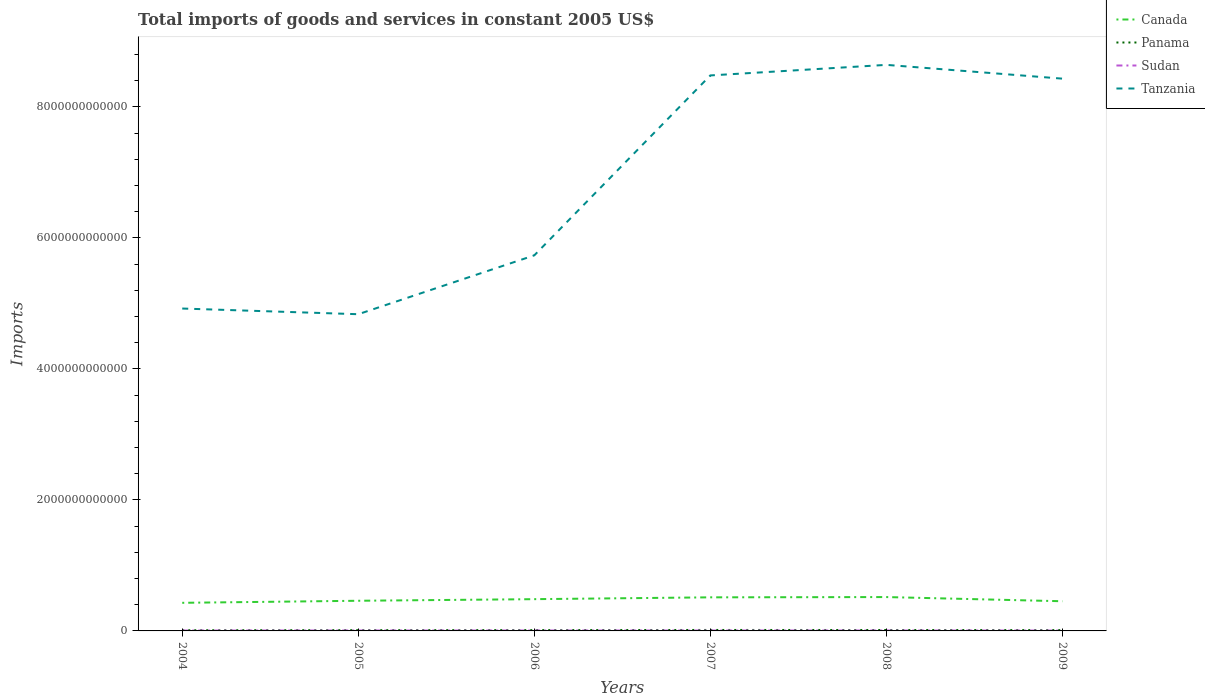Does the line corresponding to Sudan intersect with the line corresponding to Panama?
Your response must be concise. No. Is the number of lines equal to the number of legend labels?
Your answer should be very brief. Yes. Across all years, what is the maximum total imports of goods and services in Canada?
Ensure brevity in your answer.  4.29e+11. In which year was the total imports of goods and services in Tanzania maximum?
Provide a succinct answer. 2005. What is the total total imports of goods and services in Sudan in the graph?
Provide a short and direct response. 2.44e+08. What is the difference between the highest and the second highest total imports of goods and services in Canada?
Provide a succinct answer. 8.79e+1. What is the difference between the highest and the lowest total imports of goods and services in Canada?
Your response must be concise. 3. Is the total imports of goods and services in Tanzania strictly greater than the total imports of goods and services in Panama over the years?
Give a very brief answer. No. What is the difference between two consecutive major ticks on the Y-axis?
Keep it short and to the point. 2.00e+12. What is the title of the graph?
Your response must be concise. Total imports of goods and services in constant 2005 US$. What is the label or title of the Y-axis?
Provide a short and direct response. Imports. What is the Imports in Canada in 2004?
Keep it short and to the point. 4.29e+11. What is the Imports of Panama in 2004?
Offer a terse response. 1.04e+1. What is the Imports of Sudan in 2004?
Offer a terse response. 5.89e+09. What is the Imports of Tanzania in 2004?
Provide a succinct answer. 4.92e+12. What is the Imports of Canada in 2005?
Provide a succinct answer. 4.61e+11. What is the Imports of Panama in 2005?
Keep it short and to the point. 1.15e+1. What is the Imports of Sudan in 2005?
Offer a terse response. 6.37e+09. What is the Imports of Tanzania in 2005?
Your response must be concise. 4.84e+12. What is the Imports in Canada in 2006?
Provide a succinct answer. 4.85e+11. What is the Imports in Panama in 2006?
Your response must be concise. 1.24e+1. What is the Imports in Sudan in 2006?
Your answer should be compact. 6.09e+09. What is the Imports of Tanzania in 2006?
Make the answer very short. 5.73e+12. What is the Imports of Canada in 2007?
Provide a short and direct response. 5.13e+11. What is the Imports in Panama in 2007?
Ensure brevity in your answer.  1.46e+1. What is the Imports of Sudan in 2007?
Your response must be concise. 6.11e+09. What is the Imports of Tanzania in 2007?
Your response must be concise. 8.48e+12. What is the Imports of Canada in 2008?
Ensure brevity in your answer.  5.17e+11. What is the Imports of Panama in 2008?
Ensure brevity in your answer.  1.40e+1. What is the Imports of Sudan in 2008?
Ensure brevity in your answer.  6.12e+09. What is the Imports in Tanzania in 2008?
Your answer should be very brief. 8.64e+12. What is the Imports of Canada in 2009?
Offer a terse response. 4.53e+11. What is the Imports of Panama in 2009?
Offer a terse response. 1.23e+1. What is the Imports in Sudan in 2009?
Your answer should be compact. 5.68e+09. What is the Imports in Tanzania in 2009?
Offer a terse response. 8.43e+12. Across all years, what is the maximum Imports of Canada?
Keep it short and to the point. 5.17e+11. Across all years, what is the maximum Imports of Panama?
Offer a terse response. 1.46e+1. Across all years, what is the maximum Imports of Sudan?
Offer a very short reply. 6.37e+09. Across all years, what is the maximum Imports of Tanzania?
Make the answer very short. 8.64e+12. Across all years, what is the minimum Imports in Canada?
Provide a short and direct response. 4.29e+11. Across all years, what is the minimum Imports in Panama?
Keep it short and to the point. 1.04e+1. Across all years, what is the minimum Imports of Sudan?
Ensure brevity in your answer.  5.68e+09. Across all years, what is the minimum Imports of Tanzania?
Make the answer very short. 4.84e+12. What is the total Imports in Canada in the graph?
Provide a succinct answer. 2.86e+12. What is the total Imports of Panama in the graph?
Provide a short and direct response. 7.52e+1. What is the total Imports in Sudan in the graph?
Offer a very short reply. 3.62e+1. What is the total Imports of Tanzania in the graph?
Give a very brief answer. 4.11e+13. What is the difference between the Imports of Canada in 2004 and that in 2005?
Keep it short and to the point. -3.14e+1. What is the difference between the Imports of Panama in 2004 and that in 2005?
Your answer should be compact. -1.16e+09. What is the difference between the Imports in Sudan in 2004 and that in 2005?
Your answer should be very brief. -4.80e+08. What is the difference between the Imports of Tanzania in 2004 and that in 2005?
Offer a terse response. 8.68e+1. What is the difference between the Imports in Canada in 2004 and that in 2006?
Keep it short and to the point. -5.58e+1. What is the difference between the Imports of Panama in 2004 and that in 2006?
Offer a very short reply. -2.02e+09. What is the difference between the Imports in Sudan in 2004 and that in 2006?
Your answer should be very brief. -2.00e+08. What is the difference between the Imports of Tanzania in 2004 and that in 2006?
Give a very brief answer. -8.12e+11. What is the difference between the Imports of Canada in 2004 and that in 2007?
Provide a short and direct response. -8.37e+1. What is the difference between the Imports in Panama in 2004 and that in 2007?
Make the answer very short. -4.25e+09. What is the difference between the Imports in Sudan in 2004 and that in 2007?
Provide a succinct answer. -2.18e+08. What is the difference between the Imports of Tanzania in 2004 and that in 2007?
Offer a terse response. -3.56e+12. What is the difference between the Imports in Canada in 2004 and that in 2008?
Your response must be concise. -8.79e+1. What is the difference between the Imports in Panama in 2004 and that in 2008?
Offer a very short reply. -3.59e+09. What is the difference between the Imports in Sudan in 2004 and that in 2008?
Provide a succinct answer. -2.36e+08. What is the difference between the Imports in Tanzania in 2004 and that in 2008?
Provide a succinct answer. -3.72e+12. What is the difference between the Imports in Canada in 2004 and that in 2009?
Ensure brevity in your answer.  -2.40e+1. What is the difference between the Imports of Panama in 2004 and that in 2009?
Offer a very short reply. -1.88e+09. What is the difference between the Imports in Sudan in 2004 and that in 2009?
Offer a terse response. 2.12e+08. What is the difference between the Imports of Tanzania in 2004 and that in 2009?
Provide a succinct answer. -3.51e+12. What is the difference between the Imports of Canada in 2005 and that in 2006?
Offer a very short reply. -2.44e+1. What is the difference between the Imports in Panama in 2005 and that in 2006?
Offer a very short reply. -8.57e+08. What is the difference between the Imports of Sudan in 2005 and that in 2006?
Ensure brevity in your answer.  2.80e+08. What is the difference between the Imports of Tanzania in 2005 and that in 2006?
Offer a very short reply. -8.99e+11. What is the difference between the Imports in Canada in 2005 and that in 2007?
Offer a very short reply. -5.23e+1. What is the difference between the Imports of Panama in 2005 and that in 2007?
Offer a terse response. -3.09e+09. What is the difference between the Imports in Sudan in 2005 and that in 2007?
Offer a very short reply. 2.62e+08. What is the difference between the Imports in Tanzania in 2005 and that in 2007?
Your answer should be compact. -3.65e+12. What is the difference between the Imports of Canada in 2005 and that in 2008?
Make the answer very short. -5.65e+1. What is the difference between the Imports of Panama in 2005 and that in 2008?
Your response must be concise. -2.43e+09. What is the difference between the Imports in Sudan in 2005 and that in 2008?
Offer a very short reply. 2.44e+08. What is the difference between the Imports in Tanzania in 2005 and that in 2008?
Offer a very short reply. -3.81e+12. What is the difference between the Imports of Canada in 2005 and that in 2009?
Give a very brief answer. 7.42e+09. What is the difference between the Imports in Panama in 2005 and that in 2009?
Give a very brief answer. -7.20e+08. What is the difference between the Imports in Sudan in 2005 and that in 2009?
Provide a short and direct response. 6.92e+08. What is the difference between the Imports of Tanzania in 2005 and that in 2009?
Keep it short and to the point. -3.60e+12. What is the difference between the Imports in Canada in 2006 and that in 2007?
Your answer should be compact. -2.79e+1. What is the difference between the Imports of Panama in 2006 and that in 2007?
Provide a short and direct response. -2.24e+09. What is the difference between the Imports in Sudan in 2006 and that in 2007?
Your response must be concise. -1.80e+07. What is the difference between the Imports of Tanzania in 2006 and that in 2007?
Make the answer very short. -2.75e+12. What is the difference between the Imports in Canada in 2006 and that in 2008?
Offer a terse response. -3.21e+1. What is the difference between the Imports in Panama in 2006 and that in 2008?
Provide a short and direct response. -1.57e+09. What is the difference between the Imports of Sudan in 2006 and that in 2008?
Provide a short and direct response. -3.60e+07. What is the difference between the Imports in Tanzania in 2006 and that in 2008?
Ensure brevity in your answer.  -2.91e+12. What is the difference between the Imports in Canada in 2006 and that in 2009?
Give a very brief answer. 3.19e+1. What is the difference between the Imports in Panama in 2006 and that in 2009?
Offer a terse response. 1.37e+08. What is the difference between the Imports in Sudan in 2006 and that in 2009?
Give a very brief answer. 4.12e+08. What is the difference between the Imports of Tanzania in 2006 and that in 2009?
Your answer should be very brief. -2.70e+12. What is the difference between the Imports in Canada in 2007 and that in 2008?
Offer a very short reply. -4.19e+09. What is the difference between the Imports of Panama in 2007 and that in 2008?
Offer a very short reply. 6.65e+08. What is the difference between the Imports in Sudan in 2007 and that in 2008?
Your response must be concise. -1.79e+07. What is the difference between the Imports of Tanzania in 2007 and that in 2008?
Your response must be concise. -1.61e+11. What is the difference between the Imports of Canada in 2007 and that in 2009?
Offer a very short reply. 5.97e+1. What is the difference between the Imports in Panama in 2007 and that in 2009?
Offer a terse response. 2.37e+09. What is the difference between the Imports of Sudan in 2007 and that in 2009?
Offer a terse response. 4.30e+08. What is the difference between the Imports of Tanzania in 2007 and that in 2009?
Ensure brevity in your answer.  4.91e+1. What is the difference between the Imports of Canada in 2008 and that in 2009?
Your answer should be very brief. 6.39e+1. What is the difference between the Imports of Panama in 2008 and that in 2009?
Keep it short and to the point. 1.71e+09. What is the difference between the Imports in Sudan in 2008 and that in 2009?
Offer a terse response. 4.48e+08. What is the difference between the Imports in Tanzania in 2008 and that in 2009?
Give a very brief answer. 2.11e+11. What is the difference between the Imports of Canada in 2004 and the Imports of Panama in 2005?
Ensure brevity in your answer.  4.18e+11. What is the difference between the Imports of Canada in 2004 and the Imports of Sudan in 2005?
Ensure brevity in your answer.  4.23e+11. What is the difference between the Imports in Canada in 2004 and the Imports in Tanzania in 2005?
Make the answer very short. -4.41e+12. What is the difference between the Imports in Panama in 2004 and the Imports in Sudan in 2005?
Provide a succinct answer. 4.01e+09. What is the difference between the Imports in Panama in 2004 and the Imports in Tanzania in 2005?
Keep it short and to the point. -4.83e+12. What is the difference between the Imports of Sudan in 2004 and the Imports of Tanzania in 2005?
Keep it short and to the point. -4.83e+12. What is the difference between the Imports of Canada in 2004 and the Imports of Panama in 2006?
Offer a very short reply. 4.17e+11. What is the difference between the Imports of Canada in 2004 and the Imports of Sudan in 2006?
Provide a short and direct response. 4.23e+11. What is the difference between the Imports of Canada in 2004 and the Imports of Tanzania in 2006?
Provide a short and direct response. -5.31e+12. What is the difference between the Imports of Panama in 2004 and the Imports of Sudan in 2006?
Offer a terse response. 4.29e+09. What is the difference between the Imports in Panama in 2004 and the Imports in Tanzania in 2006?
Ensure brevity in your answer.  -5.72e+12. What is the difference between the Imports of Sudan in 2004 and the Imports of Tanzania in 2006?
Give a very brief answer. -5.73e+12. What is the difference between the Imports of Canada in 2004 and the Imports of Panama in 2007?
Ensure brevity in your answer.  4.15e+11. What is the difference between the Imports in Canada in 2004 and the Imports in Sudan in 2007?
Your answer should be very brief. 4.23e+11. What is the difference between the Imports of Canada in 2004 and the Imports of Tanzania in 2007?
Your answer should be compact. -8.05e+12. What is the difference between the Imports in Panama in 2004 and the Imports in Sudan in 2007?
Keep it short and to the point. 4.28e+09. What is the difference between the Imports in Panama in 2004 and the Imports in Tanzania in 2007?
Provide a short and direct response. -8.47e+12. What is the difference between the Imports in Sudan in 2004 and the Imports in Tanzania in 2007?
Ensure brevity in your answer.  -8.48e+12. What is the difference between the Imports in Canada in 2004 and the Imports in Panama in 2008?
Ensure brevity in your answer.  4.15e+11. What is the difference between the Imports in Canada in 2004 and the Imports in Sudan in 2008?
Your answer should be very brief. 4.23e+11. What is the difference between the Imports of Canada in 2004 and the Imports of Tanzania in 2008?
Offer a terse response. -8.21e+12. What is the difference between the Imports in Panama in 2004 and the Imports in Sudan in 2008?
Your response must be concise. 4.26e+09. What is the difference between the Imports of Panama in 2004 and the Imports of Tanzania in 2008?
Your answer should be very brief. -8.63e+12. What is the difference between the Imports in Sudan in 2004 and the Imports in Tanzania in 2008?
Give a very brief answer. -8.64e+12. What is the difference between the Imports of Canada in 2004 and the Imports of Panama in 2009?
Your response must be concise. 4.17e+11. What is the difference between the Imports of Canada in 2004 and the Imports of Sudan in 2009?
Your response must be concise. 4.23e+11. What is the difference between the Imports in Canada in 2004 and the Imports in Tanzania in 2009?
Provide a short and direct response. -8.00e+12. What is the difference between the Imports of Panama in 2004 and the Imports of Sudan in 2009?
Your answer should be very brief. 4.71e+09. What is the difference between the Imports of Panama in 2004 and the Imports of Tanzania in 2009?
Ensure brevity in your answer.  -8.42e+12. What is the difference between the Imports in Sudan in 2004 and the Imports in Tanzania in 2009?
Offer a terse response. -8.43e+12. What is the difference between the Imports of Canada in 2005 and the Imports of Panama in 2006?
Offer a very short reply. 4.48e+11. What is the difference between the Imports in Canada in 2005 and the Imports in Sudan in 2006?
Provide a succinct answer. 4.54e+11. What is the difference between the Imports of Canada in 2005 and the Imports of Tanzania in 2006?
Provide a succinct answer. -5.27e+12. What is the difference between the Imports of Panama in 2005 and the Imports of Sudan in 2006?
Offer a terse response. 5.45e+09. What is the difference between the Imports of Panama in 2005 and the Imports of Tanzania in 2006?
Ensure brevity in your answer.  -5.72e+12. What is the difference between the Imports of Sudan in 2005 and the Imports of Tanzania in 2006?
Provide a succinct answer. -5.73e+12. What is the difference between the Imports of Canada in 2005 and the Imports of Panama in 2007?
Give a very brief answer. 4.46e+11. What is the difference between the Imports in Canada in 2005 and the Imports in Sudan in 2007?
Your answer should be compact. 4.54e+11. What is the difference between the Imports of Canada in 2005 and the Imports of Tanzania in 2007?
Keep it short and to the point. -8.02e+12. What is the difference between the Imports of Panama in 2005 and the Imports of Sudan in 2007?
Provide a short and direct response. 5.44e+09. What is the difference between the Imports in Panama in 2005 and the Imports in Tanzania in 2007?
Provide a succinct answer. -8.47e+12. What is the difference between the Imports in Sudan in 2005 and the Imports in Tanzania in 2007?
Offer a very short reply. -8.48e+12. What is the difference between the Imports of Canada in 2005 and the Imports of Panama in 2008?
Your answer should be very brief. 4.47e+11. What is the difference between the Imports in Canada in 2005 and the Imports in Sudan in 2008?
Keep it short and to the point. 4.54e+11. What is the difference between the Imports in Canada in 2005 and the Imports in Tanzania in 2008?
Offer a terse response. -8.18e+12. What is the difference between the Imports in Panama in 2005 and the Imports in Sudan in 2008?
Your response must be concise. 5.42e+09. What is the difference between the Imports in Panama in 2005 and the Imports in Tanzania in 2008?
Give a very brief answer. -8.63e+12. What is the difference between the Imports in Sudan in 2005 and the Imports in Tanzania in 2008?
Offer a very short reply. -8.64e+12. What is the difference between the Imports in Canada in 2005 and the Imports in Panama in 2009?
Your answer should be very brief. 4.48e+11. What is the difference between the Imports of Canada in 2005 and the Imports of Sudan in 2009?
Make the answer very short. 4.55e+11. What is the difference between the Imports in Canada in 2005 and the Imports in Tanzania in 2009?
Your response must be concise. -7.97e+12. What is the difference between the Imports in Panama in 2005 and the Imports in Sudan in 2009?
Keep it short and to the point. 5.87e+09. What is the difference between the Imports in Panama in 2005 and the Imports in Tanzania in 2009?
Your response must be concise. -8.42e+12. What is the difference between the Imports of Sudan in 2005 and the Imports of Tanzania in 2009?
Your answer should be very brief. -8.43e+12. What is the difference between the Imports in Canada in 2006 and the Imports in Panama in 2007?
Your answer should be very brief. 4.70e+11. What is the difference between the Imports in Canada in 2006 and the Imports in Sudan in 2007?
Offer a very short reply. 4.79e+11. What is the difference between the Imports of Canada in 2006 and the Imports of Tanzania in 2007?
Offer a terse response. -8.00e+12. What is the difference between the Imports in Panama in 2006 and the Imports in Sudan in 2007?
Ensure brevity in your answer.  6.29e+09. What is the difference between the Imports of Panama in 2006 and the Imports of Tanzania in 2007?
Ensure brevity in your answer.  -8.47e+12. What is the difference between the Imports of Sudan in 2006 and the Imports of Tanzania in 2007?
Keep it short and to the point. -8.48e+12. What is the difference between the Imports in Canada in 2006 and the Imports in Panama in 2008?
Your answer should be very brief. 4.71e+11. What is the difference between the Imports in Canada in 2006 and the Imports in Sudan in 2008?
Keep it short and to the point. 4.79e+11. What is the difference between the Imports in Canada in 2006 and the Imports in Tanzania in 2008?
Provide a short and direct response. -8.16e+12. What is the difference between the Imports of Panama in 2006 and the Imports of Sudan in 2008?
Your answer should be compact. 6.27e+09. What is the difference between the Imports in Panama in 2006 and the Imports in Tanzania in 2008?
Your answer should be very brief. -8.63e+12. What is the difference between the Imports in Sudan in 2006 and the Imports in Tanzania in 2008?
Your answer should be compact. -8.64e+12. What is the difference between the Imports in Canada in 2006 and the Imports in Panama in 2009?
Ensure brevity in your answer.  4.73e+11. What is the difference between the Imports in Canada in 2006 and the Imports in Sudan in 2009?
Your answer should be very brief. 4.79e+11. What is the difference between the Imports in Canada in 2006 and the Imports in Tanzania in 2009?
Keep it short and to the point. -7.95e+12. What is the difference between the Imports in Panama in 2006 and the Imports in Sudan in 2009?
Provide a succinct answer. 6.72e+09. What is the difference between the Imports of Panama in 2006 and the Imports of Tanzania in 2009?
Give a very brief answer. -8.42e+12. What is the difference between the Imports of Sudan in 2006 and the Imports of Tanzania in 2009?
Keep it short and to the point. -8.43e+12. What is the difference between the Imports in Canada in 2007 and the Imports in Panama in 2008?
Keep it short and to the point. 4.99e+11. What is the difference between the Imports of Canada in 2007 and the Imports of Sudan in 2008?
Offer a terse response. 5.07e+11. What is the difference between the Imports of Canada in 2007 and the Imports of Tanzania in 2008?
Keep it short and to the point. -8.13e+12. What is the difference between the Imports of Panama in 2007 and the Imports of Sudan in 2008?
Give a very brief answer. 8.51e+09. What is the difference between the Imports in Panama in 2007 and the Imports in Tanzania in 2008?
Give a very brief answer. -8.63e+12. What is the difference between the Imports of Sudan in 2007 and the Imports of Tanzania in 2008?
Keep it short and to the point. -8.64e+12. What is the difference between the Imports in Canada in 2007 and the Imports in Panama in 2009?
Make the answer very short. 5.01e+11. What is the difference between the Imports in Canada in 2007 and the Imports in Sudan in 2009?
Provide a succinct answer. 5.07e+11. What is the difference between the Imports in Canada in 2007 and the Imports in Tanzania in 2009?
Your answer should be compact. -7.92e+12. What is the difference between the Imports of Panama in 2007 and the Imports of Sudan in 2009?
Your answer should be very brief. 8.96e+09. What is the difference between the Imports of Panama in 2007 and the Imports of Tanzania in 2009?
Offer a terse response. -8.42e+12. What is the difference between the Imports of Sudan in 2007 and the Imports of Tanzania in 2009?
Your response must be concise. -8.43e+12. What is the difference between the Imports in Canada in 2008 and the Imports in Panama in 2009?
Your answer should be compact. 5.05e+11. What is the difference between the Imports in Canada in 2008 and the Imports in Sudan in 2009?
Provide a succinct answer. 5.11e+11. What is the difference between the Imports in Canada in 2008 and the Imports in Tanzania in 2009?
Offer a very short reply. -7.92e+12. What is the difference between the Imports of Panama in 2008 and the Imports of Sudan in 2009?
Your answer should be very brief. 8.30e+09. What is the difference between the Imports of Panama in 2008 and the Imports of Tanzania in 2009?
Offer a terse response. -8.42e+12. What is the difference between the Imports in Sudan in 2008 and the Imports in Tanzania in 2009?
Provide a short and direct response. -8.43e+12. What is the average Imports in Canada per year?
Give a very brief answer. 4.76e+11. What is the average Imports in Panama per year?
Your answer should be very brief. 1.25e+1. What is the average Imports in Sudan per year?
Offer a very short reply. 6.04e+09. What is the average Imports in Tanzania per year?
Make the answer very short. 6.84e+12. In the year 2004, what is the difference between the Imports of Canada and Imports of Panama?
Provide a short and direct response. 4.19e+11. In the year 2004, what is the difference between the Imports in Canada and Imports in Sudan?
Keep it short and to the point. 4.23e+11. In the year 2004, what is the difference between the Imports of Canada and Imports of Tanzania?
Offer a terse response. -4.49e+12. In the year 2004, what is the difference between the Imports in Panama and Imports in Sudan?
Ensure brevity in your answer.  4.49e+09. In the year 2004, what is the difference between the Imports of Panama and Imports of Tanzania?
Keep it short and to the point. -4.91e+12. In the year 2004, what is the difference between the Imports of Sudan and Imports of Tanzania?
Provide a succinct answer. -4.92e+12. In the year 2005, what is the difference between the Imports in Canada and Imports in Panama?
Keep it short and to the point. 4.49e+11. In the year 2005, what is the difference between the Imports in Canada and Imports in Sudan?
Your answer should be compact. 4.54e+11. In the year 2005, what is the difference between the Imports in Canada and Imports in Tanzania?
Your answer should be compact. -4.38e+12. In the year 2005, what is the difference between the Imports of Panama and Imports of Sudan?
Offer a terse response. 5.17e+09. In the year 2005, what is the difference between the Imports in Panama and Imports in Tanzania?
Make the answer very short. -4.82e+12. In the year 2005, what is the difference between the Imports in Sudan and Imports in Tanzania?
Provide a short and direct response. -4.83e+12. In the year 2006, what is the difference between the Imports of Canada and Imports of Panama?
Your answer should be very brief. 4.73e+11. In the year 2006, what is the difference between the Imports of Canada and Imports of Sudan?
Your answer should be compact. 4.79e+11. In the year 2006, what is the difference between the Imports in Canada and Imports in Tanzania?
Offer a very short reply. -5.25e+12. In the year 2006, what is the difference between the Imports of Panama and Imports of Sudan?
Your response must be concise. 6.31e+09. In the year 2006, what is the difference between the Imports of Panama and Imports of Tanzania?
Offer a very short reply. -5.72e+12. In the year 2006, what is the difference between the Imports of Sudan and Imports of Tanzania?
Your response must be concise. -5.73e+12. In the year 2007, what is the difference between the Imports of Canada and Imports of Panama?
Keep it short and to the point. 4.98e+11. In the year 2007, what is the difference between the Imports of Canada and Imports of Sudan?
Offer a very short reply. 5.07e+11. In the year 2007, what is the difference between the Imports in Canada and Imports in Tanzania?
Give a very brief answer. -7.97e+12. In the year 2007, what is the difference between the Imports of Panama and Imports of Sudan?
Your answer should be compact. 8.53e+09. In the year 2007, what is the difference between the Imports in Panama and Imports in Tanzania?
Keep it short and to the point. -8.47e+12. In the year 2007, what is the difference between the Imports in Sudan and Imports in Tanzania?
Your response must be concise. -8.48e+12. In the year 2008, what is the difference between the Imports in Canada and Imports in Panama?
Provide a short and direct response. 5.03e+11. In the year 2008, what is the difference between the Imports in Canada and Imports in Sudan?
Your answer should be very brief. 5.11e+11. In the year 2008, what is the difference between the Imports in Canada and Imports in Tanzania?
Give a very brief answer. -8.13e+12. In the year 2008, what is the difference between the Imports in Panama and Imports in Sudan?
Ensure brevity in your answer.  7.85e+09. In the year 2008, what is the difference between the Imports in Panama and Imports in Tanzania?
Provide a succinct answer. -8.63e+12. In the year 2008, what is the difference between the Imports in Sudan and Imports in Tanzania?
Offer a terse response. -8.64e+12. In the year 2009, what is the difference between the Imports of Canada and Imports of Panama?
Offer a terse response. 4.41e+11. In the year 2009, what is the difference between the Imports in Canada and Imports in Sudan?
Ensure brevity in your answer.  4.47e+11. In the year 2009, what is the difference between the Imports in Canada and Imports in Tanzania?
Give a very brief answer. -7.98e+12. In the year 2009, what is the difference between the Imports of Panama and Imports of Sudan?
Give a very brief answer. 6.59e+09. In the year 2009, what is the difference between the Imports of Panama and Imports of Tanzania?
Give a very brief answer. -8.42e+12. In the year 2009, what is the difference between the Imports in Sudan and Imports in Tanzania?
Provide a short and direct response. -8.43e+12. What is the ratio of the Imports of Canada in 2004 to that in 2005?
Ensure brevity in your answer.  0.93. What is the ratio of the Imports in Panama in 2004 to that in 2005?
Ensure brevity in your answer.  0.9. What is the ratio of the Imports in Sudan in 2004 to that in 2005?
Your response must be concise. 0.92. What is the ratio of the Imports in Canada in 2004 to that in 2006?
Your answer should be very brief. 0.88. What is the ratio of the Imports of Panama in 2004 to that in 2006?
Give a very brief answer. 0.84. What is the ratio of the Imports in Sudan in 2004 to that in 2006?
Offer a terse response. 0.97. What is the ratio of the Imports of Tanzania in 2004 to that in 2006?
Keep it short and to the point. 0.86. What is the ratio of the Imports in Canada in 2004 to that in 2007?
Offer a very short reply. 0.84. What is the ratio of the Imports of Panama in 2004 to that in 2007?
Ensure brevity in your answer.  0.71. What is the ratio of the Imports of Sudan in 2004 to that in 2007?
Your answer should be compact. 0.96. What is the ratio of the Imports in Tanzania in 2004 to that in 2007?
Give a very brief answer. 0.58. What is the ratio of the Imports of Canada in 2004 to that in 2008?
Offer a very short reply. 0.83. What is the ratio of the Imports in Panama in 2004 to that in 2008?
Offer a terse response. 0.74. What is the ratio of the Imports in Sudan in 2004 to that in 2008?
Offer a very short reply. 0.96. What is the ratio of the Imports in Tanzania in 2004 to that in 2008?
Ensure brevity in your answer.  0.57. What is the ratio of the Imports of Canada in 2004 to that in 2009?
Give a very brief answer. 0.95. What is the ratio of the Imports in Panama in 2004 to that in 2009?
Your response must be concise. 0.85. What is the ratio of the Imports of Sudan in 2004 to that in 2009?
Provide a succinct answer. 1.04. What is the ratio of the Imports in Tanzania in 2004 to that in 2009?
Your answer should be very brief. 0.58. What is the ratio of the Imports in Canada in 2005 to that in 2006?
Offer a very short reply. 0.95. What is the ratio of the Imports in Panama in 2005 to that in 2006?
Ensure brevity in your answer.  0.93. What is the ratio of the Imports in Sudan in 2005 to that in 2006?
Your answer should be compact. 1.05. What is the ratio of the Imports of Tanzania in 2005 to that in 2006?
Ensure brevity in your answer.  0.84. What is the ratio of the Imports in Canada in 2005 to that in 2007?
Make the answer very short. 0.9. What is the ratio of the Imports of Panama in 2005 to that in 2007?
Give a very brief answer. 0.79. What is the ratio of the Imports in Sudan in 2005 to that in 2007?
Offer a very short reply. 1.04. What is the ratio of the Imports of Tanzania in 2005 to that in 2007?
Make the answer very short. 0.57. What is the ratio of the Imports in Canada in 2005 to that in 2008?
Provide a short and direct response. 0.89. What is the ratio of the Imports of Panama in 2005 to that in 2008?
Provide a succinct answer. 0.83. What is the ratio of the Imports in Sudan in 2005 to that in 2008?
Make the answer very short. 1.04. What is the ratio of the Imports in Tanzania in 2005 to that in 2008?
Make the answer very short. 0.56. What is the ratio of the Imports in Canada in 2005 to that in 2009?
Your response must be concise. 1.02. What is the ratio of the Imports in Panama in 2005 to that in 2009?
Your answer should be very brief. 0.94. What is the ratio of the Imports of Sudan in 2005 to that in 2009?
Ensure brevity in your answer.  1.12. What is the ratio of the Imports in Tanzania in 2005 to that in 2009?
Offer a terse response. 0.57. What is the ratio of the Imports of Canada in 2006 to that in 2007?
Offer a very short reply. 0.95. What is the ratio of the Imports of Panama in 2006 to that in 2007?
Offer a very short reply. 0.85. What is the ratio of the Imports in Sudan in 2006 to that in 2007?
Ensure brevity in your answer.  1. What is the ratio of the Imports of Tanzania in 2006 to that in 2007?
Keep it short and to the point. 0.68. What is the ratio of the Imports in Canada in 2006 to that in 2008?
Offer a terse response. 0.94. What is the ratio of the Imports in Panama in 2006 to that in 2008?
Your answer should be compact. 0.89. What is the ratio of the Imports in Sudan in 2006 to that in 2008?
Your answer should be compact. 0.99. What is the ratio of the Imports in Tanzania in 2006 to that in 2008?
Keep it short and to the point. 0.66. What is the ratio of the Imports in Canada in 2006 to that in 2009?
Your answer should be very brief. 1.07. What is the ratio of the Imports in Panama in 2006 to that in 2009?
Keep it short and to the point. 1.01. What is the ratio of the Imports of Sudan in 2006 to that in 2009?
Provide a short and direct response. 1.07. What is the ratio of the Imports of Tanzania in 2006 to that in 2009?
Your answer should be very brief. 0.68. What is the ratio of the Imports of Panama in 2007 to that in 2008?
Offer a very short reply. 1.05. What is the ratio of the Imports in Tanzania in 2007 to that in 2008?
Offer a terse response. 0.98. What is the ratio of the Imports of Canada in 2007 to that in 2009?
Provide a short and direct response. 1.13. What is the ratio of the Imports of Panama in 2007 to that in 2009?
Provide a succinct answer. 1.19. What is the ratio of the Imports in Sudan in 2007 to that in 2009?
Keep it short and to the point. 1.08. What is the ratio of the Imports in Tanzania in 2007 to that in 2009?
Offer a terse response. 1.01. What is the ratio of the Imports in Canada in 2008 to that in 2009?
Offer a very short reply. 1.14. What is the ratio of the Imports in Panama in 2008 to that in 2009?
Keep it short and to the point. 1.14. What is the ratio of the Imports of Sudan in 2008 to that in 2009?
Offer a very short reply. 1.08. What is the difference between the highest and the second highest Imports in Canada?
Give a very brief answer. 4.19e+09. What is the difference between the highest and the second highest Imports in Panama?
Ensure brevity in your answer.  6.65e+08. What is the difference between the highest and the second highest Imports in Sudan?
Provide a short and direct response. 2.44e+08. What is the difference between the highest and the second highest Imports of Tanzania?
Your response must be concise. 1.61e+11. What is the difference between the highest and the lowest Imports of Canada?
Offer a terse response. 8.79e+1. What is the difference between the highest and the lowest Imports in Panama?
Your response must be concise. 4.25e+09. What is the difference between the highest and the lowest Imports in Sudan?
Give a very brief answer. 6.92e+08. What is the difference between the highest and the lowest Imports in Tanzania?
Ensure brevity in your answer.  3.81e+12. 